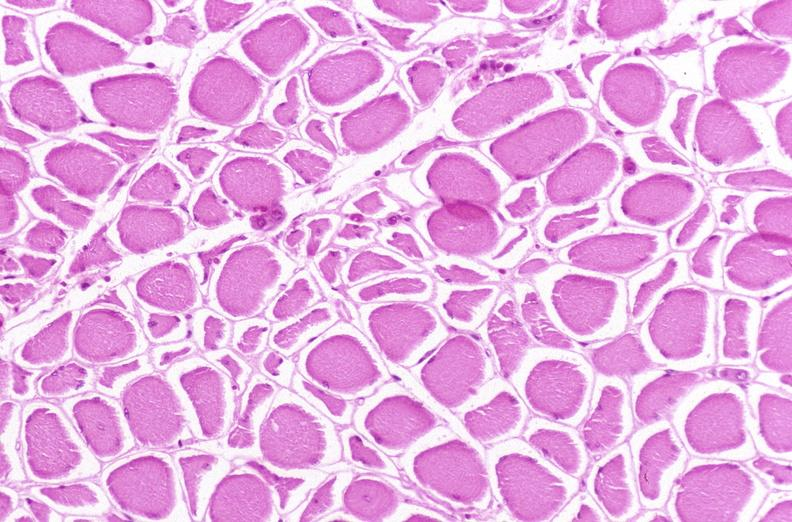s endocrine present?
Answer the question using a single word or phrase. No 